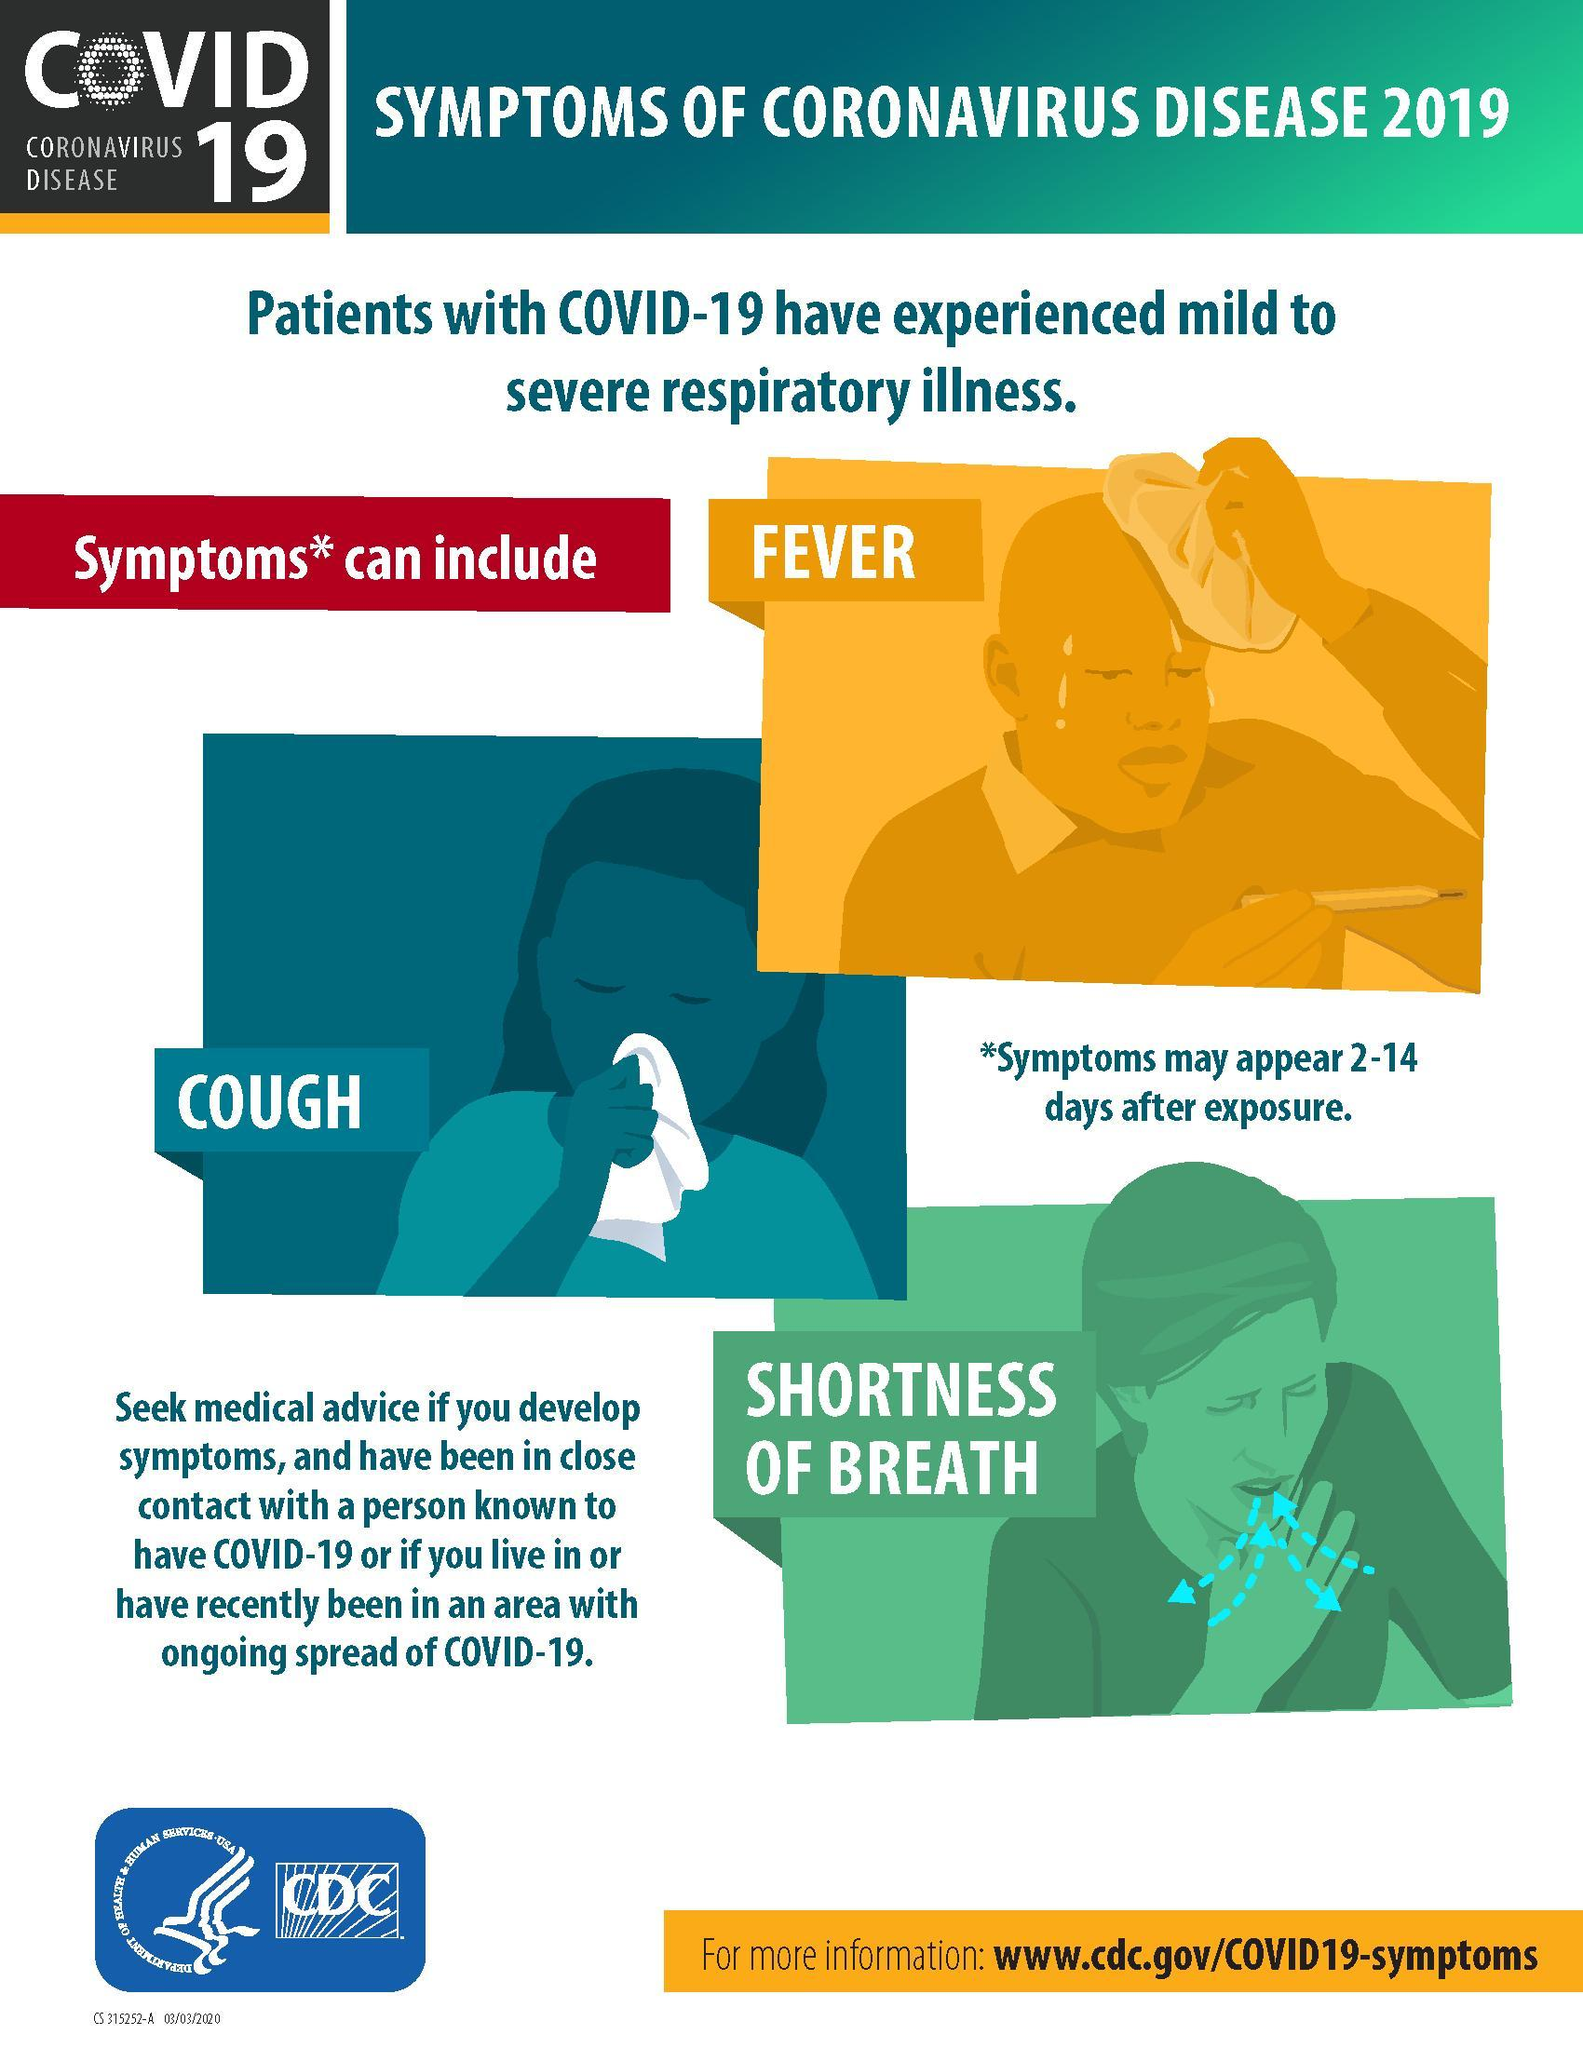What is the background color given to "Shortness of breath"- red, orange, blue, green?
Answer the question with a short phrase. green What is the background color given to Cough- red, orange, blue, green? blue How many symptoms of corona are listed in the infographic? 3 What are the health issues which can occur due to corona? Fever, cough, shortness of breath What is the third symptom of corona as mentioned in the infographic? Shortness of Breath What is the background color given to Fever- red, orange, blue, green? orange What is the second health issue which can occur due to corona? cough 